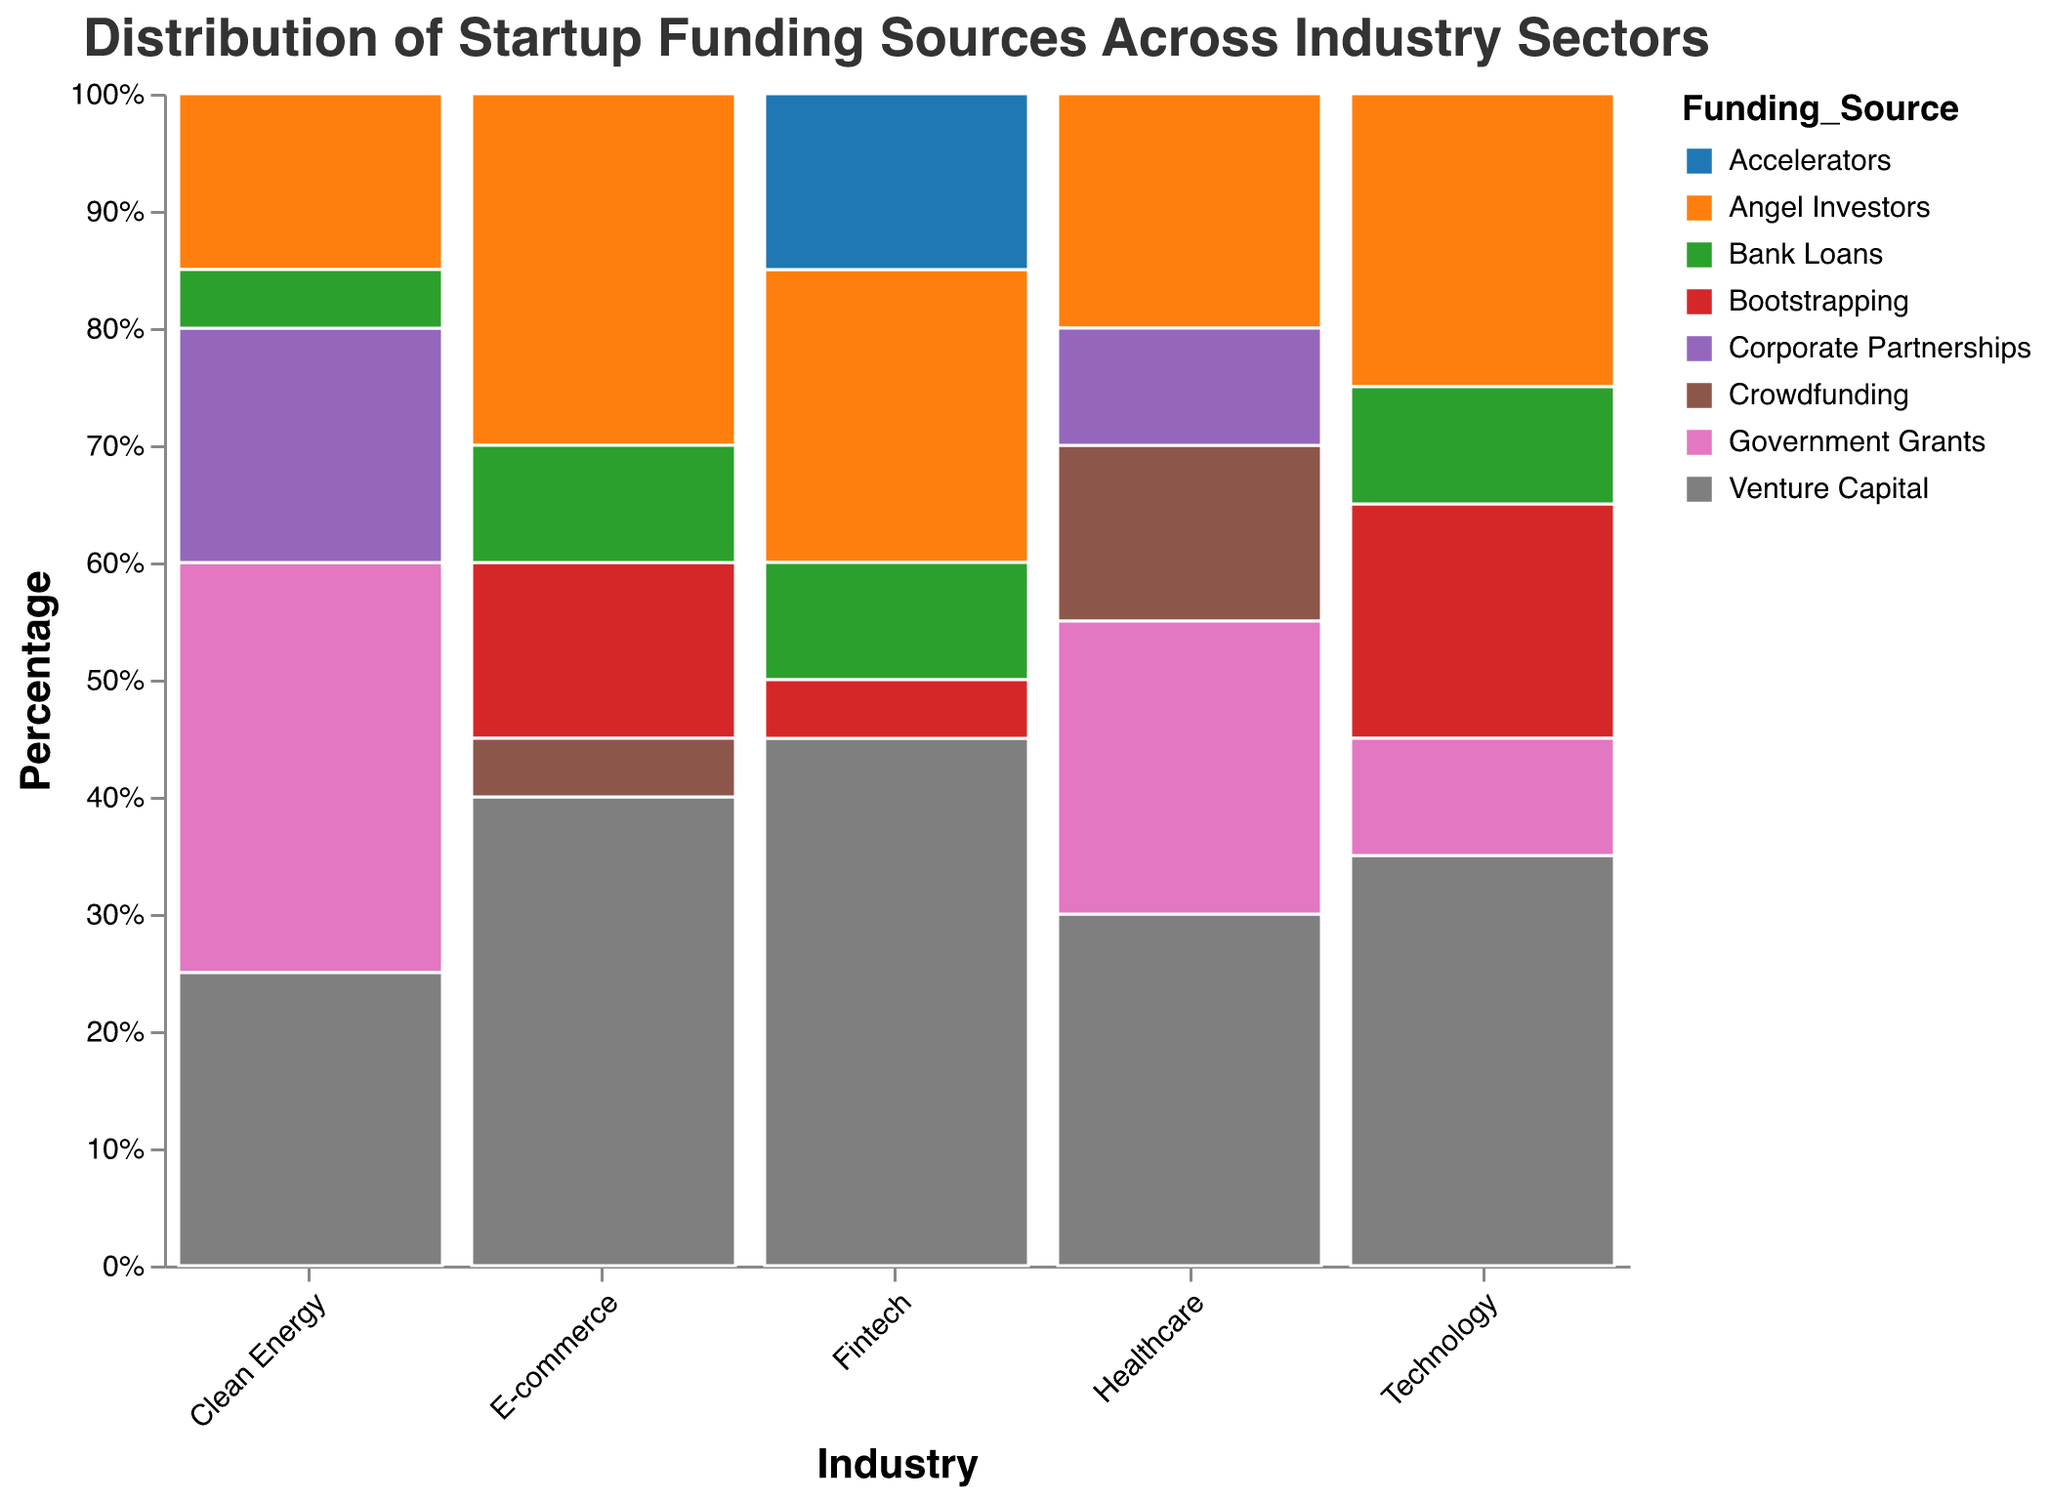How many industry sectors are represented in the plot? The x-axis displays the sectors, and we can count the distinct sectors shown. They are Technology, Healthcare, E-commerce, Clean Energy, and Fintech.
Answer: 5 Which industry sector has the highest percentage of venture capital funding? By examining the Venture Capital segment for each industry, Fintech has the largest Venture Capital section, representing 45%.
Answer: Fintech What is the combined percentage of Bootstrapping funding in Technology and Fintech sectors? Technology has 20% Bootstrapping, and Fintech has 5%. Adding them together: 20% + 5% = 25%.
Answer: 25% Which industry sector relies most heavily on Government Grants? Comparing the Government Grants segments, Clean Energy has the largest portion at 35%.
Answer: Clean Energy How does the percentage of Angel Investors compare between Technology and Healthcare? Technology has 25% from Angel Investors, and Healthcare has 20%. 25% is greater than 20%.
Answer: Technology > Healthcare What is the least common funding source in E-commerce? E-commerce's least common funding source is Crowdfunding at 5%.
Answer: Crowdfunding Which funding source is unique to Healthcare in this dataset? Among the funding sources listed, Corporate Partnerships appear only in Healthcare.
Answer: Corporate Partnerships What percentage of Healthcare funding comes from Crowdfunding and Government Grants combined? Healthcare has 15% from Crowdfunding and 25% from Government Grants. Adding them together: 15% + 25% = 40%.
Answer: 40% What funding source in Clean Energy has the closest percentage to Venture Capital in Technology? Clean Energy's Venture Capital is 25%, which is closest to Technology's Angel Investors at 25%.
Answer: Angel Investors Compare the total percentage of Bank Loans across all sectors. Summing up Bank Loans: 
- Technology: 10%
- E-commerce: 10%
- Clean Energy: 5%
- Fintech: 10%
Total: 10% + 10% + 5% + 10% = 35%
Answer: 35% 